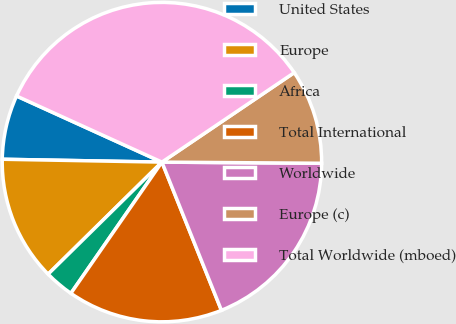Convert chart. <chart><loc_0><loc_0><loc_500><loc_500><pie_chart><fcel>United States<fcel>Europe<fcel>Africa<fcel>Total International<fcel>Worldwide<fcel>Europe (c)<fcel>Total Worldwide (mboed)<nl><fcel>6.51%<fcel>12.66%<fcel>2.97%<fcel>15.73%<fcel>18.81%<fcel>9.58%<fcel>33.74%<nl></chart> 